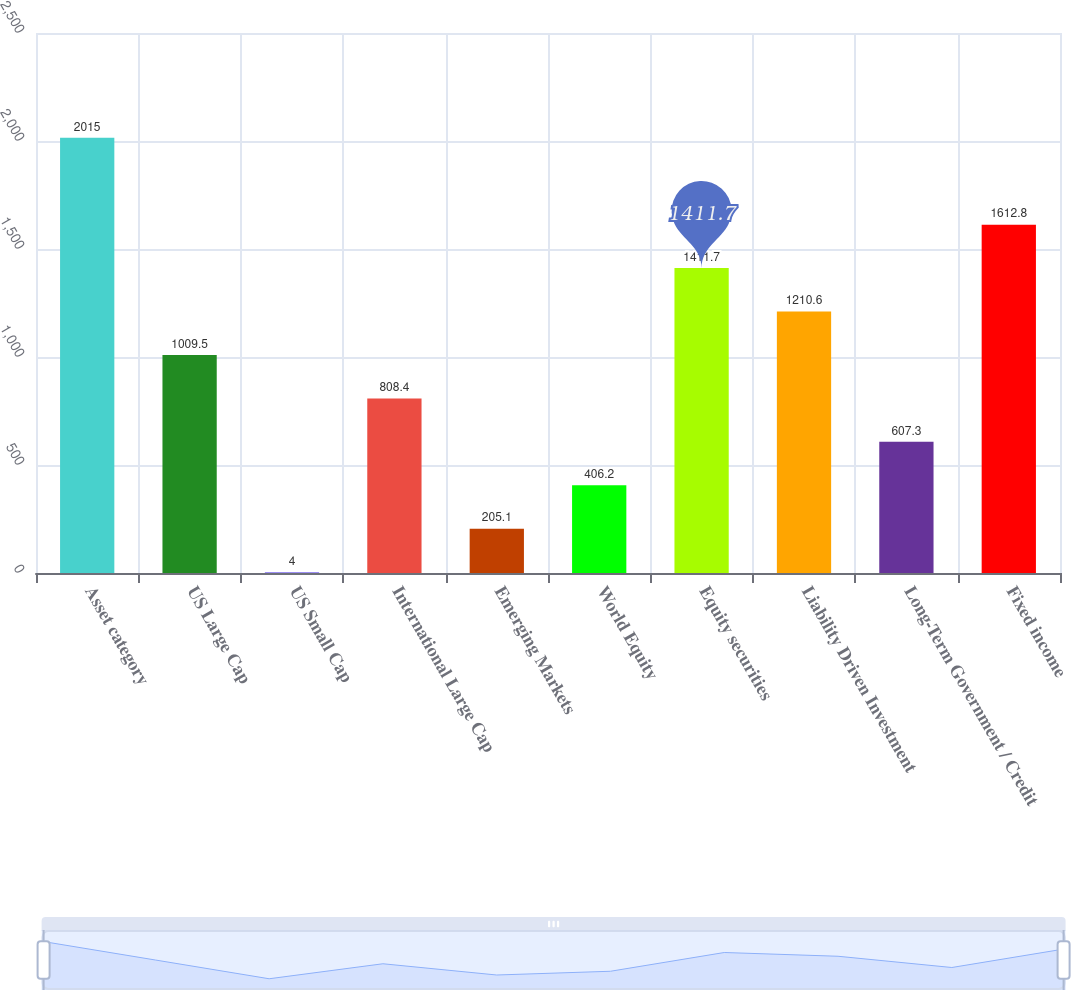<chart> <loc_0><loc_0><loc_500><loc_500><bar_chart><fcel>Asset category<fcel>US Large Cap<fcel>US Small Cap<fcel>International Large Cap<fcel>Emerging Markets<fcel>World Equity<fcel>Equity securities<fcel>Liability Driven Investment<fcel>Long-Term Government / Credit<fcel>Fixed income<nl><fcel>2015<fcel>1009.5<fcel>4<fcel>808.4<fcel>205.1<fcel>406.2<fcel>1411.7<fcel>1210.6<fcel>607.3<fcel>1612.8<nl></chart> 